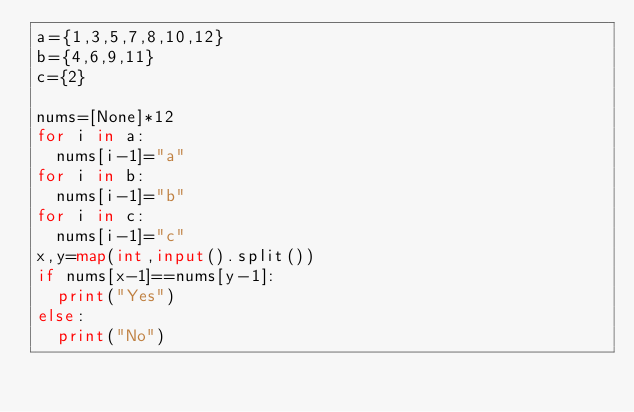Convert code to text. <code><loc_0><loc_0><loc_500><loc_500><_Python_>a={1,3,5,7,8,10,12}
b={4,6,9,11}
c={2}

nums=[None]*12
for i in a:
  nums[i-1]="a"
for i in b:
  nums[i-1]="b"
for i in c:
  nums[i-1]="c"
x,y=map(int,input().split())
if nums[x-1]==nums[y-1]:
  print("Yes")
else:
  print("No")</code> 